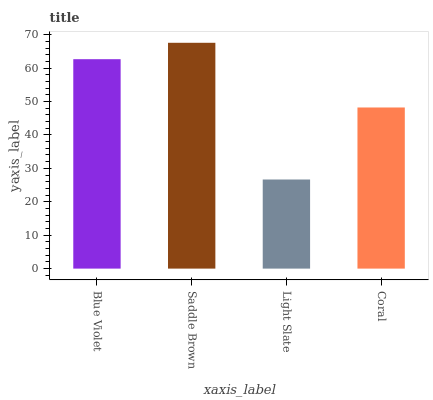Is Light Slate the minimum?
Answer yes or no. Yes. Is Saddle Brown the maximum?
Answer yes or no. Yes. Is Saddle Brown the minimum?
Answer yes or no. No. Is Light Slate the maximum?
Answer yes or no. No. Is Saddle Brown greater than Light Slate?
Answer yes or no. Yes. Is Light Slate less than Saddle Brown?
Answer yes or no. Yes. Is Light Slate greater than Saddle Brown?
Answer yes or no. No. Is Saddle Brown less than Light Slate?
Answer yes or no. No. Is Blue Violet the high median?
Answer yes or no. Yes. Is Coral the low median?
Answer yes or no. Yes. Is Coral the high median?
Answer yes or no. No. Is Light Slate the low median?
Answer yes or no. No. 